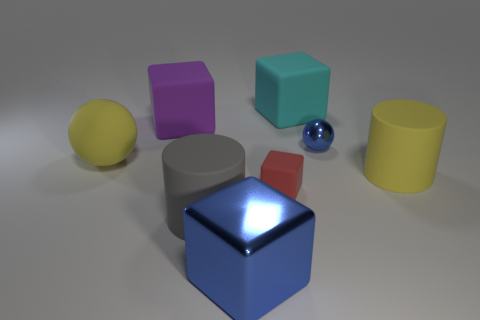Subtract all large metallic cubes. How many cubes are left? 3 Subtract all purple cubes. How many cubes are left? 3 Subtract 2 cubes. How many cubes are left? 2 Add 8 small blue objects. How many small blue objects exist? 9 Add 1 small red matte objects. How many objects exist? 9 Subtract 0 brown cubes. How many objects are left? 8 Subtract all balls. How many objects are left? 6 Subtract all purple balls. Subtract all brown blocks. How many balls are left? 2 Subtract all green blocks. How many blue balls are left? 1 Subtract all blue metal blocks. Subtract all red metal spheres. How many objects are left? 7 